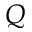Convert formula to latex. <formula><loc_0><loc_0><loc_500><loc_500>Q</formula> 